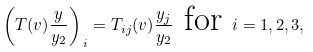Convert formula to latex. <formula><loc_0><loc_0><loc_500><loc_500>\left ( T ( v ) \frac { y } { y _ { 2 } } \right ) _ { \, i } = T _ { i j } ( v ) \frac { y _ { j } } { y _ { 2 } } \text { for } i = 1 , 2 , 3 ,</formula> 